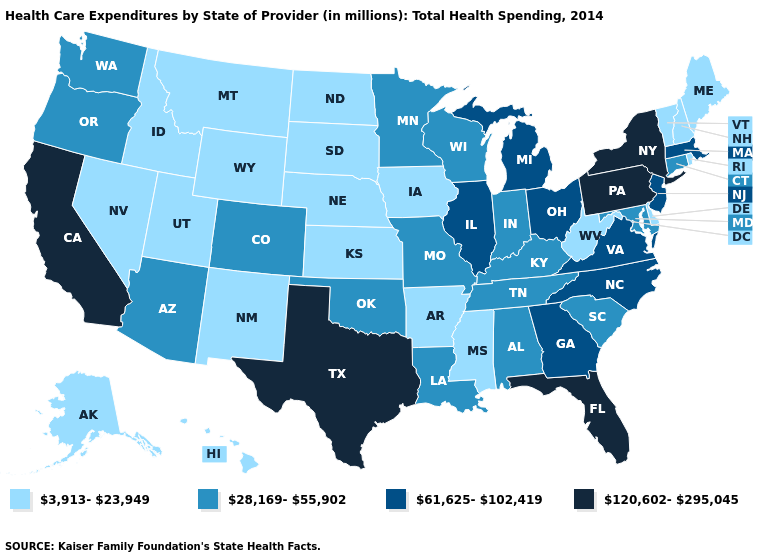Does the first symbol in the legend represent the smallest category?
Write a very short answer. Yes. What is the value of Alabama?
Answer briefly. 28,169-55,902. What is the highest value in the South ?
Quick response, please. 120,602-295,045. Does Texas have the lowest value in the South?
Write a very short answer. No. Does Virginia have the same value as South Carolina?
Keep it brief. No. What is the highest value in the USA?
Keep it brief. 120,602-295,045. Does the map have missing data?
Concise answer only. No. Does Texas have the highest value in the USA?
Keep it brief. Yes. Name the states that have a value in the range 3,913-23,949?
Give a very brief answer. Alaska, Arkansas, Delaware, Hawaii, Idaho, Iowa, Kansas, Maine, Mississippi, Montana, Nebraska, Nevada, New Hampshire, New Mexico, North Dakota, Rhode Island, South Dakota, Utah, Vermont, West Virginia, Wyoming. What is the value of Indiana?
Write a very short answer. 28,169-55,902. What is the value of Florida?
Write a very short answer. 120,602-295,045. What is the highest value in the USA?
Be succinct. 120,602-295,045. What is the value of Mississippi?
Concise answer only. 3,913-23,949. Does Washington have the highest value in the USA?
Keep it brief. No. Name the states that have a value in the range 120,602-295,045?
Short answer required. California, Florida, New York, Pennsylvania, Texas. 